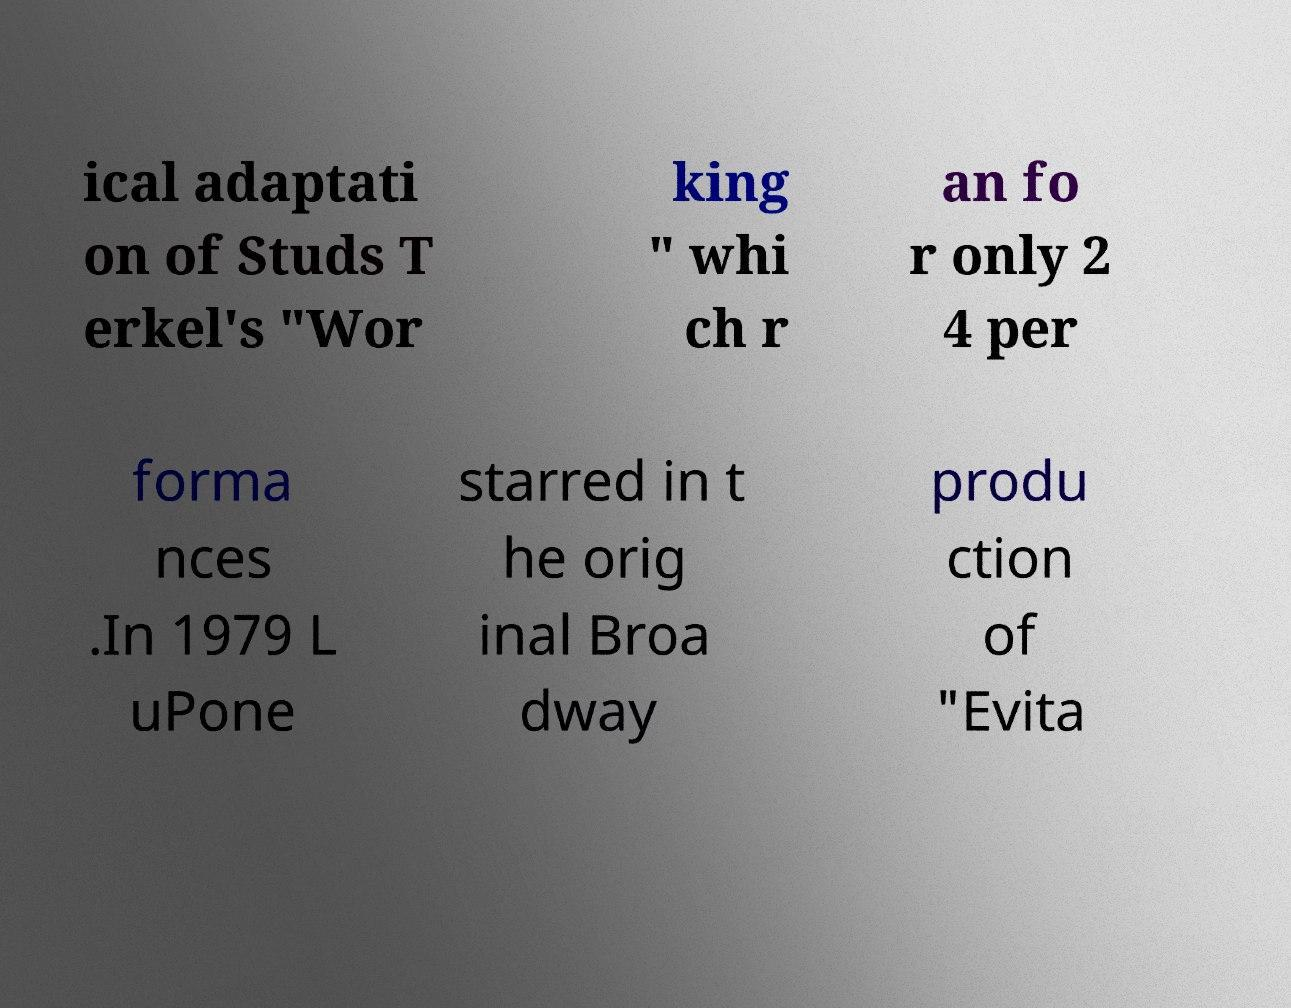Can you read and provide the text displayed in the image?This photo seems to have some interesting text. Can you extract and type it out for me? ical adaptati on of Studs T erkel's "Wor king " whi ch r an fo r only 2 4 per forma nces .In 1979 L uPone starred in t he orig inal Broa dway produ ction of "Evita 